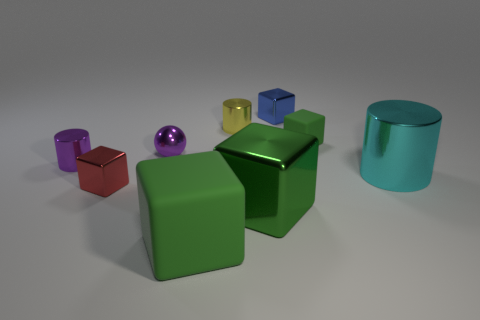There is a metallic cylinder that is the same color as the metal sphere; what size is it?
Offer a terse response. Small. Does the large green metallic object have the same shape as the rubber object that is to the right of the blue cube?
Your answer should be very brief. Yes. How many red metallic cubes have the same size as the ball?
Your answer should be very brief. 1. What number of blocks are right of the purple object that is behind the small shiny cylinder to the left of the large matte block?
Your response must be concise. 4. Are there the same number of large green blocks in front of the tiny blue thing and green rubber blocks in front of the red metallic object?
Provide a short and direct response. No. How many small red shiny objects have the same shape as the large cyan object?
Keep it short and to the point. 0. Are there any tiny blue objects that have the same material as the large cylinder?
Your answer should be very brief. Yes. There is a small object that is the same color as the tiny sphere; what shape is it?
Keep it short and to the point. Cylinder. What number of big green matte blocks are there?
Keep it short and to the point. 1. How many cubes are red things or small blue objects?
Offer a terse response. 2. 